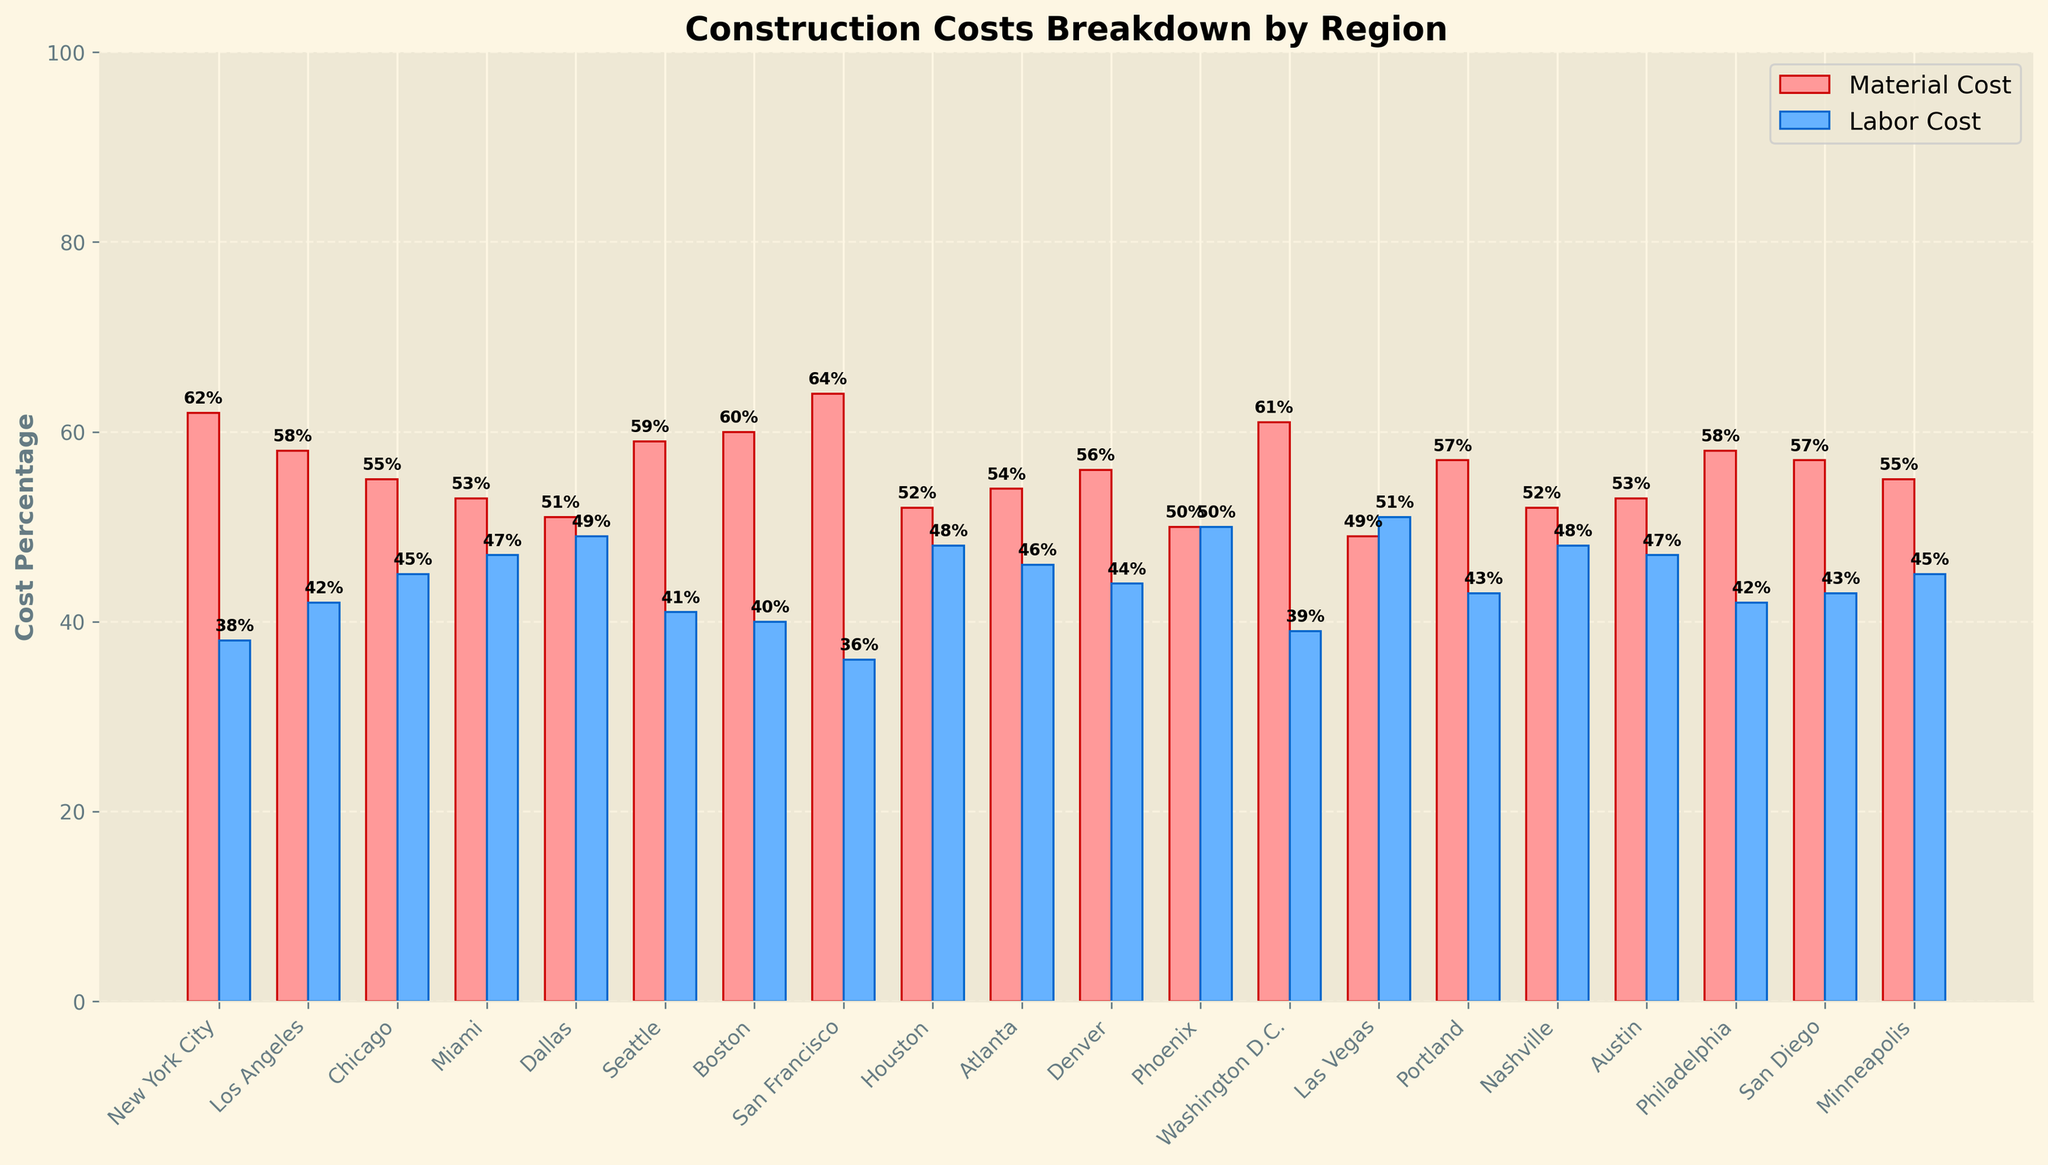Which region has the highest material cost percentage? By observing the bar heights for material costs, San Francisco has the tallest bar, indicating the highest material cost percentage.
Answer: San Francisco Which region has the highest labor cost percentage? By observing the bar heights for labor costs, Las Vegas has the tallest bar, indicating the highest labor cost percentage.
Answer: Las Vegas What is the difference in material cost percentage between New York City and Los Angeles? The material cost in New York City is 62%, and in Los Angeles, it is 58%. The difference is 62% - 58% = 4%.
Answer: 4% Which regions have an equal percentage of material and labor costs? Phoenix has material and labor costs bars of equal height, both at 50%, indicating equal costs.
Answer: Phoenix What is the average material cost percentage for all regions? Sum of material costs for all regions: 62 + 58 + 55 + 53 + 51 + 59 + 60 + 64 + 52 + 54 + 56 + 50 + 61 + 49 + 57 + 52 + 53 + 58 + 57 + 55 = 1066. There are 20 regions, so the average is 1066/20 = 53.3%.
Answer: 53.3% What region has the closest labor cost percentage to the average of all regions' labor cost percentages? First, calculate the average labor cost percentage as (38 + 42 + 45 + 47 + 49 + 41 + 40 + 36 + 48 + 46 + 44 + 50 + 39 + 51 + 43 + 48 + 47 + 42 + 43 + 45)/20 = 44. The closest region to this average value in labor costs is Denver, with a labor cost percentage of 44%.
Answer: Denver Which two regions have the smallest difference in their material cost percentages? The regions with the smallest difference in material cost percentages are Miami and Austin, both at 53%, resulting in a difference of 0%.
Answer: Miami and Austin 